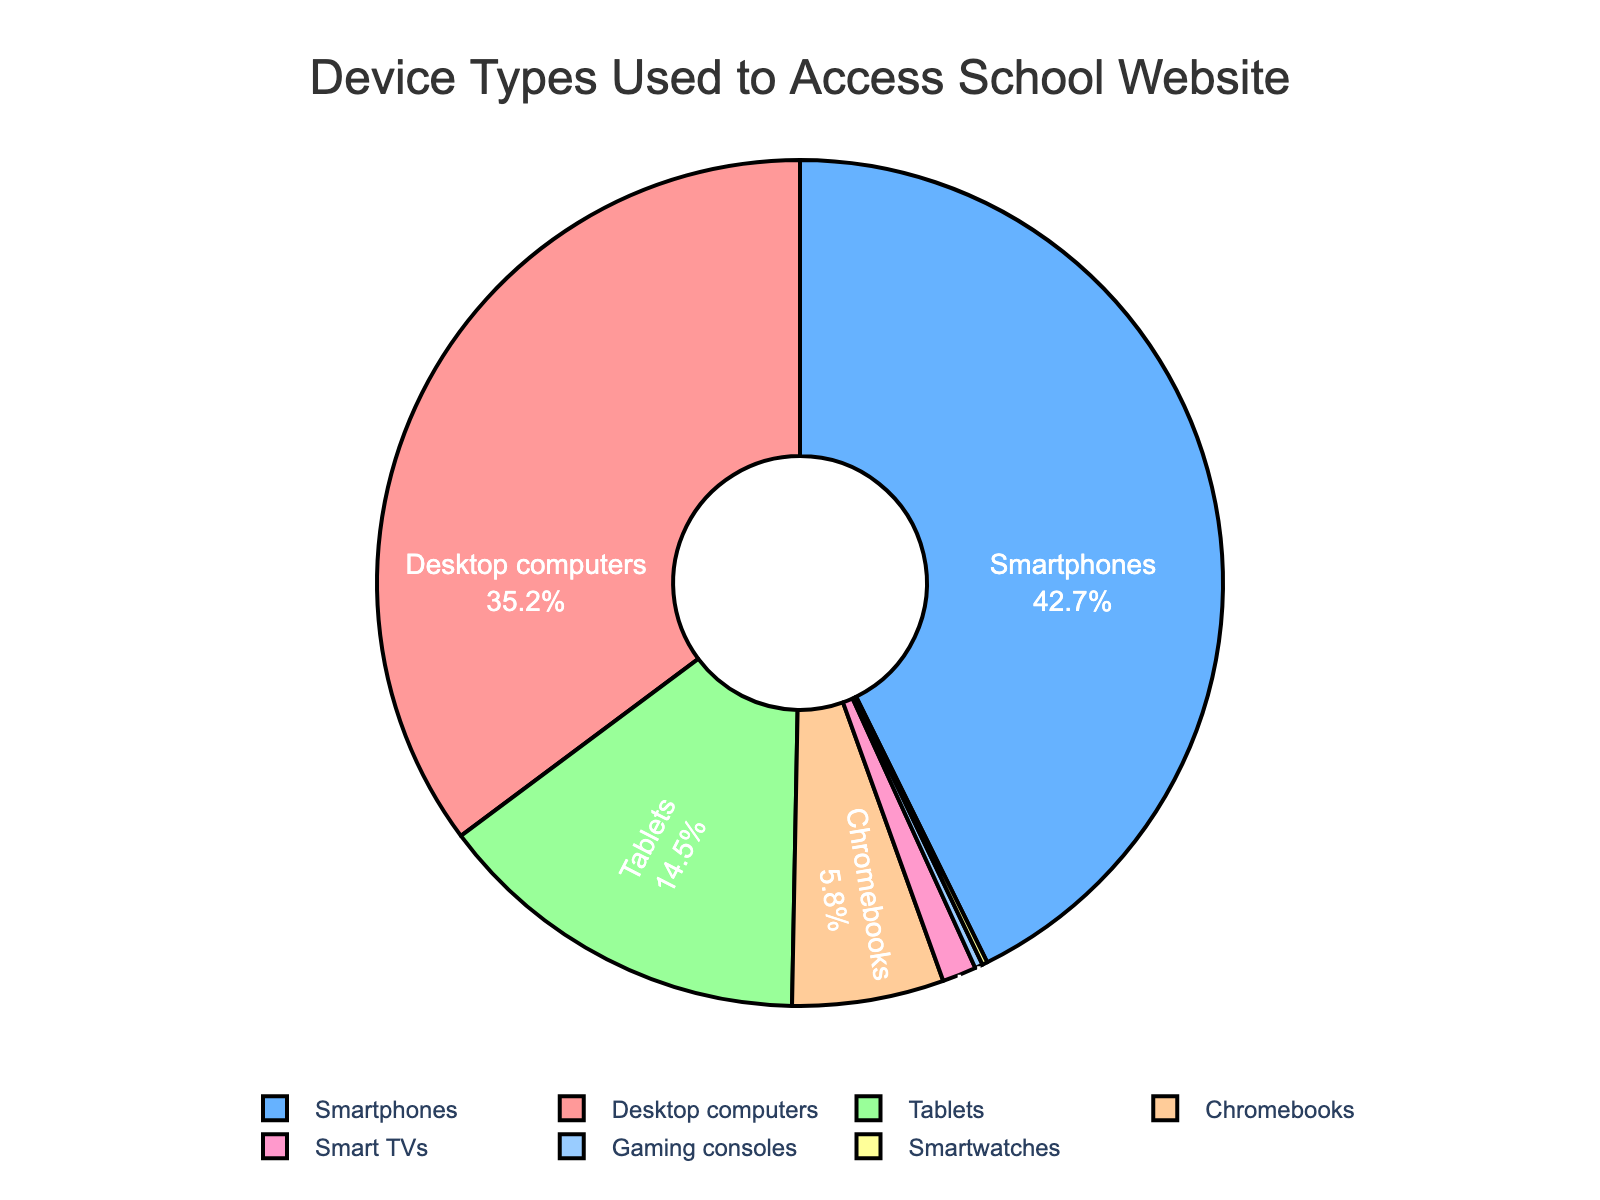Which device type has the highest proportion of users accessing the school's website? The figure shows different slices representing various device types. The largest slice is labeled "Smartphones" with 42.7%.
Answer: Smartphones What percentage of users access the website using tablets? To find the percentage, look at the slice labeled "Tablets" in the chart. It's labeled with 14.5%.
Answer: 14.5% How much greater is the percentage of smartphone users than the percentage of desktop users? Find the difference between the percentage of users accessing via smartphones (42.7%) and desktops (35.2%). Subtract 35.2 from 42.7 to get the difference.
Answer: 7.5% What is the total percentage of users accessing the website via Chromebooks, Smart TVs, Gaming consoles, and Smartwatches combined? Sum the percentages of these four device types: Chromebooks (5.8%), Smart TVs (1.3%), Gaming consoles (0.3%), and Smartwatches (0.2%). Adding them together: 5.8 + 1.3 + 0.3 + 0.2 = 7.6
Answer: 7.6 What is the proportion of users using devices other than smartphones and desktops? Sum the percentages of all devices excluding smartphones (42.7%) and desktops (35.2%). Remaining devices: Tablets (14.5%), Chromebooks (5.8%), Smart TVs (1.3%), Gaming consoles (0.3%), Smartwatches (0.2%). Adding them: 14.5 + 5.8 + 1.3 + 0.3 + 0.2 = 22.1
Answer: 22.1 Which device type is represented by the slice colored in blue? The color blue in the pie chart is used for the "Smartphones" segment, according to the figure labels and color associations.
Answer: Smartphones Is the sum of the users accessing the website via tablets and Chromebooks greater than the users accessing via desktops? Sum the percentages for tablets (14.5%) and Chromebooks (5.8%) and compare with desktops (35.2%). The combined percentage: 14.5 + 5.8 = 20.3, which is less than 35.2.
Answer: No How much smaller is the proportion of users using Smartwatches compared to Gaming consoles? Find the difference between Gaming consoles (0.3%) and Smartwatches (0.2%). Subtract 0.2 from 0.3.
Answer: 0.1 